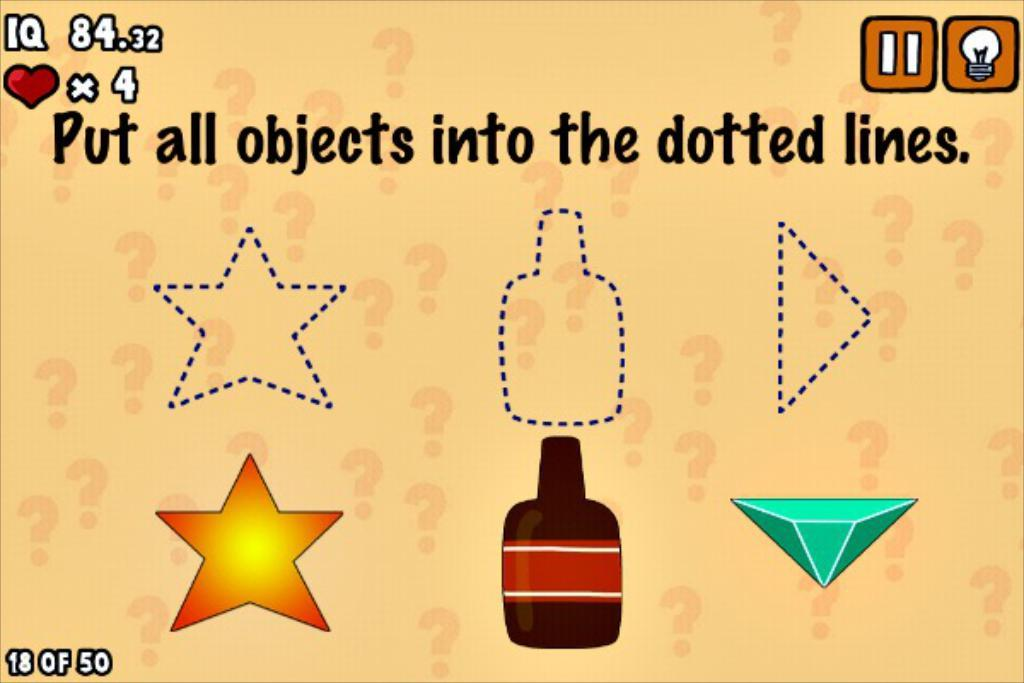<image>
Give a short and clear explanation of the subsequent image. a picture with put all objects into the dotted lines. on it 